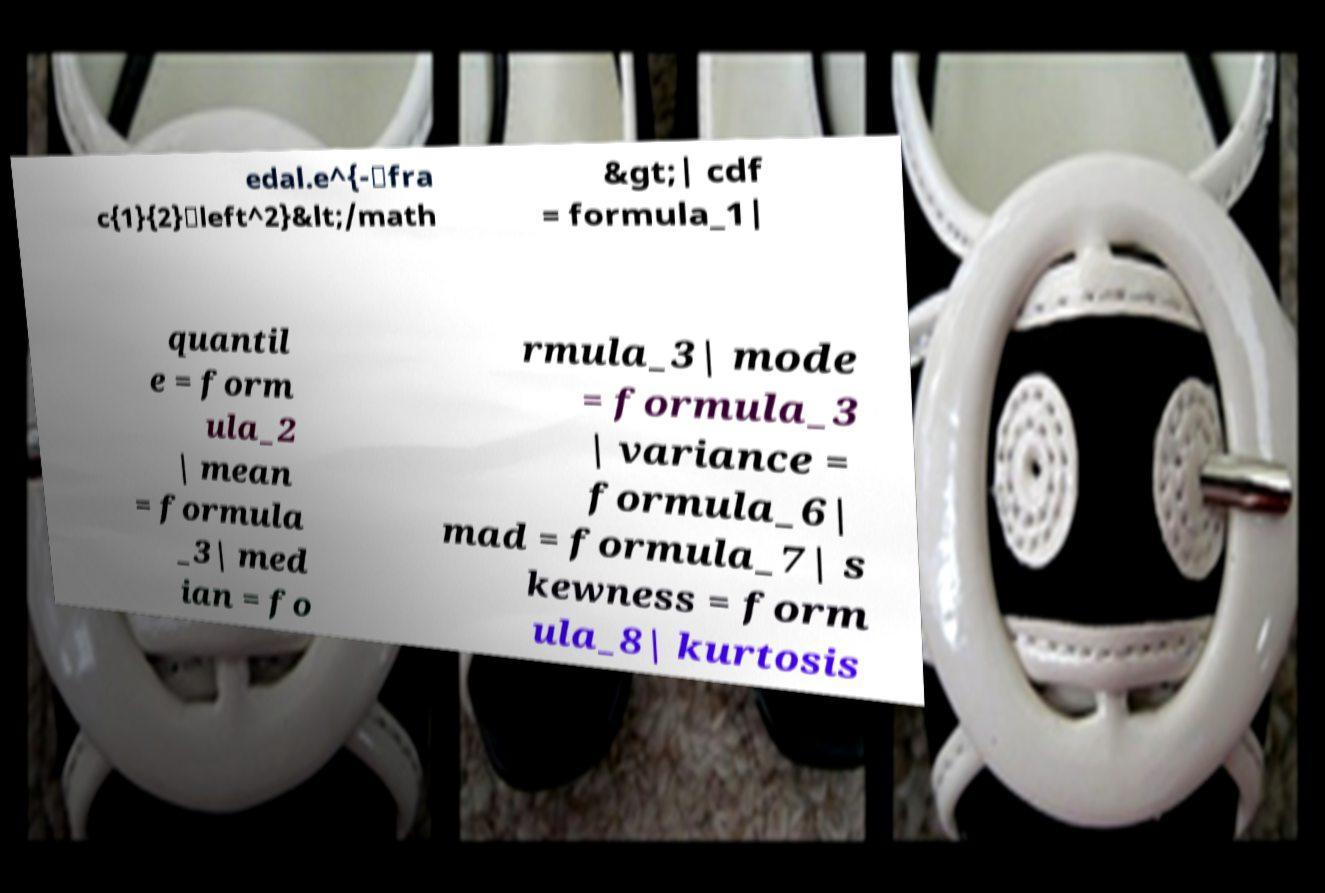Please identify and transcribe the text found in this image. edal.e^{-\fra c{1}{2}\left^2}&lt;/math &gt;| cdf = formula_1| quantil e = form ula_2 | mean = formula _3| med ian = fo rmula_3| mode = formula_3 | variance = formula_6| mad = formula_7| s kewness = form ula_8| kurtosis 